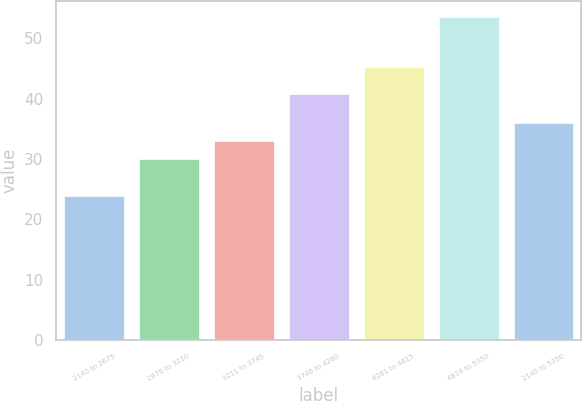Convert chart to OTSL. <chart><loc_0><loc_0><loc_500><loc_500><bar_chart><fcel>2140 to 2675<fcel>2676 to 3210<fcel>3211 to 3745<fcel>3746 to 4280<fcel>4281 to 4815<fcel>4816 to 5350<fcel>2140 to 5350<nl><fcel>23.82<fcel>29.99<fcel>32.96<fcel>40.75<fcel>45.25<fcel>53.5<fcel>35.93<nl></chart> 